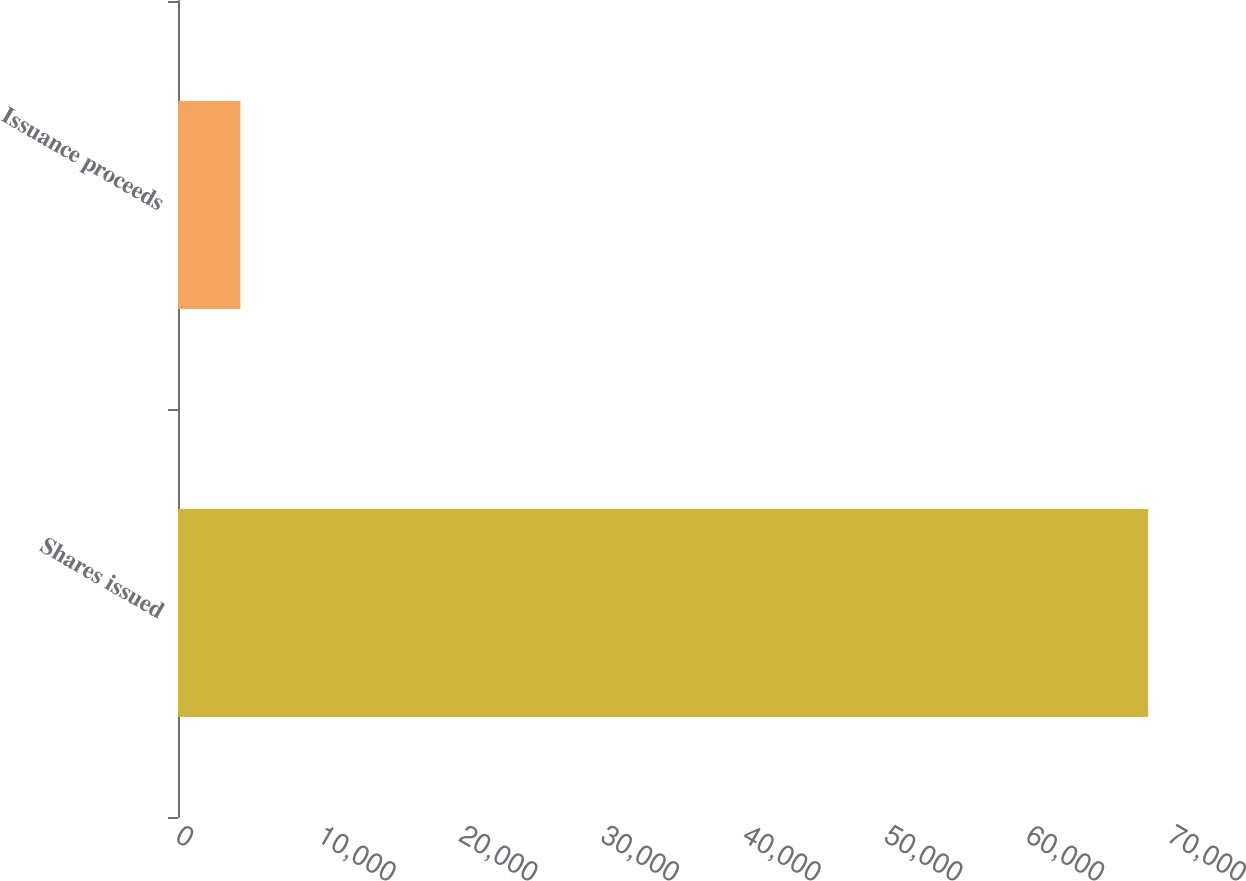Convert chart. <chart><loc_0><loc_0><loc_500><loc_500><bar_chart><fcel>Shares issued<fcel>Issuance proceeds<nl><fcel>68462<fcel>4404<nl></chart> 